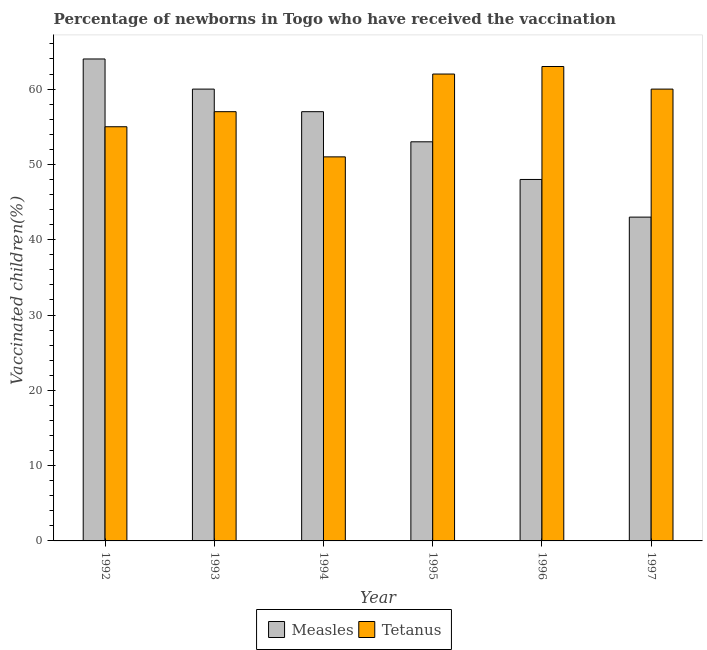Are the number of bars per tick equal to the number of legend labels?
Offer a very short reply. Yes. How many bars are there on the 5th tick from the left?
Offer a very short reply. 2. How many bars are there on the 6th tick from the right?
Provide a succinct answer. 2. What is the percentage of newborns who received vaccination for tetanus in 1995?
Make the answer very short. 62. Across all years, what is the maximum percentage of newborns who received vaccination for measles?
Keep it short and to the point. 64. Across all years, what is the minimum percentage of newborns who received vaccination for tetanus?
Your answer should be very brief. 51. What is the total percentage of newborns who received vaccination for measles in the graph?
Ensure brevity in your answer.  325. What is the difference between the percentage of newborns who received vaccination for tetanus in 1992 and that in 1993?
Give a very brief answer. -2. What is the difference between the percentage of newborns who received vaccination for measles in 1994 and the percentage of newborns who received vaccination for tetanus in 1992?
Give a very brief answer. -7. What is the average percentage of newborns who received vaccination for measles per year?
Your response must be concise. 54.17. What is the ratio of the percentage of newborns who received vaccination for tetanus in 1995 to that in 1997?
Ensure brevity in your answer.  1.03. What is the difference between the highest and the second highest percentage of newborns who received vaccination for measles?
Your answer should be very brief. 4. What is the difference between the highest and the lowest percentage of newborns who received vaccination for measles?
Offer a very short reply. 21. In how many years, is the percentage of newborns who received vaccination for measles greater than the average percentage of newborns who received vaccination for measles taken over all years?
Keep it short and to the point. 3. What does the 1st bar from the left in 1994 represents?
Offer a terse response. Measles. What does the 1st bar from the right in 1994 represents?
Keep it short and to the point. Tetanus. How many bars are there?
Offer a terse response. 12. Are all the bars in the graph horizontal?
Keep it short and to the point. No. How many years are there in the graph?
Keep it short and to the point. 6. What is the difference between two consecutive major ticks on the Y-axis?
Provide a short and direct response. 10. Are the values on the major ticks of Y-axis written in scientific E-notation?
Your answer should be very brief. No. How are the legend labels stacked?
Give a very brief answer. Horizontal. What is the title of the graph?
Make the answer very short. Percentage of newborns in Togo who have received the vaccination. Does "Crop" appear as one of the legend labels in the graph?
Ensure brevity in your answer.  No. What is the label or title of the X-axis?
Keep it short and to the point. Year. What is the label or title of the Y-axis?
Provide a short and direct response. Vaccinated children(%)
. What is the Vaccinated children(%)
 of Tetanus in 1994?
Your answer should be very brief. 51. What is the Vaccinated children(%)
 in Measles in 1995?
Provide a short and direct response. 53. What is the Vaccinated children(%)
 in Measles in 1997?
Provide a short and direct response. 43. Across all years, what is the maximum Vaccinated children(%)
 of Tetanus?
Ensure brevity in your answer.  63. Across all years, what is the minimum Vaccinated children(%)
 in Measles?
Provide a short and direct response. 43. Across all years, what is the minimum Vaccinated children(%)
 of Tetanus?
Provide a short and direct response. 51. What is the total Vaccinated children(%)
 of Measles in the graph?
Ensure brevity in your answer.  325. What is the total Vaccinated children(%)
 of Tetanus in the graph?
Give a very brief answer. 348. What is the difference between the Vaccinated children(%)
 in Tetanus in 1992 and that in 1993?
Offer a terse response. -2. What is the difference between the Vaccinated children(%)
 in Tetanus in 1992 and that in 1994?
Provide a succinct answer. 4. What is the difference between the Vaccinated children(%)
 in Tetanus in 1992 and that in 1995?
Give a very brief answer. -7. What is the difference between the Vaccinated children(%)
 in Measles in 1992 and that in 1997?
Offer a very short reply. 21. What is the difference between the Vaccinated children(%)
 in Tetanus in 1993 and that in 1994?
Provide a short and direct response. 6. What is the difference between the Vaccinated children(%)
 of Measles in 1993 and that in 1995?
Offer a very short reply. 7. What is the difference between the Vaccinated children(%)
 in Tetanus in 1993 and that in 1995?
Offer a terse response. -5. What is the difference between the Vaccinated children(%)
 of Tetanus in 1993 and that in 1996?
Your answer should be very brief. -6. What is the difference between the Vaccinated children(%)
 in Tetanus in 1993 and that in 1997?
Your response must be concise. -3. What is the difference between the Vaccinated children(%)
 in Measles in 1994 and that in 1995?
Provide a short and direct response. 4. What is the difference between the Vaccinated children(%)
 of Tetanus in 1994 and that in 1995?
Give a very brief answer. -11. What is the difference between the Vaccinated children(%)
 in Measles in 1994 and that in 1997?
Your answer should be compact. 14. What is the difference between the Vaccinated children(%)
 of Tetanus in 1994 and that in 1997?
Keep it short and to the point. -9. What is the difference between the Vaccinated children(%)
 in Tetanus in 1995 and that in 1996?
Your response must be concise. -1. What is the difference between the Vaccinated children(%)
 in Measles in 1995 and that in 1997?
Offer a very short reply. 10. What is the difference between the Vaccinated children(%)
 of Tetanus in 1995 and that in 1997?
Ensure brevity in your answer.  2. What is the difference between the Vaccinated children(%)
 of Measles in 1992 and the Vaccinated children(%)
 of Tetanus in 1993?
Keep it short and to the point. 7. What is the difference between the Vaccinated children(%)
 in Measles in 1993 and the Vaccinated children(%)
 in Tetanus in 1996?
Give a very brief answer. -3. What is the difference between the Vaccinated children(%)
 in Measles in 1993 and the Vaccinated children(%)
 in Tetanus in 1997?
Offer a terse response. 0. What is the difference between the Vaccinated children(%)
 of Measles in 1994 and the Vaccinated children(%)
 of Tetanus in 1995?
Give a very brief answer. -5. What is the difference between the Vaccinated children(%)
 in Measles in 1994 and the Vaccinated children(%)
 in Tetanus in 1996?
Your response must be concise. -6. What is the difference between the Vaccinated children(%)
 of Measles in 1995 and the Vaccinated children(%)
 of Tetanus in 1996?
Provide a succinct answer. -10. What is the average Vaccinated children(%)
 of Measles per year?
Offer a terse response. 54.17. In the year 1993, what is the difference between the Vaccinated children(%)
 in Measles and Vaccinated children(%)
 in Tetanus?
Your response must be concise. 3. In the year 1995, what is the difference between the Vaccinated children(%)
 of Measles and Vaccinated children(%)
 of Tetanus?
Provide a short and direct response. -9. In the year 1996, what is the difference between the Vaccinated children(%)
 in Measles and Vaccinated children(%)
 in Tetanus?
Offer a very short reply. -15. What is the ratio of the Vaccinated children(%)
 of Measles in 1992 to that in 1993?
Offer a very short reply. 1.07. What is the ratio of the Vaccinated children(%)
 in Tetanus in 1992 to that in 1993?
Offer a terse response. 0.96. What is the ratio of the Vaccinated children(%)
 in Measles in 1992 to that in 1994?
Make the answer very short. 1.12. What is the ratio of the Vaccinated children(%)
 of Tetanus in 1992 to that in 1994?
Ensure brevity in your answer.  1.08. What is the ratio of the Vaccinated children(%)
 of Measles in 1992 to that in 1995?
Offer a very short reply. 1.21. What is the ratio of the Vaccinated children(%)
 of Tetanus in 1992 to that in 1995?
Keep it short and to the point. 0.89. What is the ratio of the Vaccinated children(%)
 in Measles in 1992 to that in 1996?
Ensure brevity in your answer.  1.33. What is the ratio of the Vaccinated children(%)
 in Tetanus in 1992 to that in 1996?
Your answer should be very brief. 0.87. What is the ratio of the Vaccinated children(%)
 of Measles in 1992 to that in 1997?
Provide a short and direct response. 1.49. What is the ratio of the Vaccinated children(%)
 in Measles in 1993 to that in 1994?
Make the answer very short. 1.05. What is the ratio of the Vaccinated children(%)
 in Tetanus in 1993 to that in 1994?
Ensure brevity in your answer.  1.12. What is the ratio of the Vaccinated children(%)
 in Measles in 1993 to that in 1995?
Provide a short and direct response. 1.13. What is the ratio of the Vaccinated children(%)
 of Tetanus in 1993 to that in 1995?
Offer a very short reply. 0.92. What is the ratio of the Vaccinated children(%)
 of Measles in 1993 to that in 1996?
Provide a succinct answer. 1.25. What is the ratio of the Vaccinated children(%)
 in Tetanus in 1993 to that in 1996?
Your answer should be compact. 0.9. What is the ratio of the Vaccinated children(%)
 in Measles in 1993 to that in 1997?
Provide a short and direct response. 1.4. What is the ratio of the Vaccinated children(%)
 in Measles in 1994 to that in 1995?
Ensure brevity in your answer.  1.08. What is the ratio of the Vaccinated children(%)
 of Tetanus in 1994 to that in 1995?
Provide a short and direct response. 0.82. What is the ratio of the Vaccinated children(%)
 in Measles in 1994 to that in 1996?
Your answer should be very brief. 1.19. What is the ratio of the Vaccinated children(%)
 in Tetanus in 1994 to that in 1996?
Provide a short and direct response. 0.81. What is the ratio of the Vaccinated children(%)
 of Measles in 1994 to that in 1997?
Make the answer very short. 1.33. What is the ratio of the Vaccinated children(%)
 of Tetanus in 1994 to that in 1997?
Provide a succinct answer. 0.85. What is the ratio of the Vaccinated children(%)
 in Measles in 1995 to that in 1996?
Make the answer very short. 1.1. What is the ratio of the Vaccinated children(%)
 of Tetanus in 1995 to that in 1996?
Provide a short and direct response. 0.98. What is the ratio of the Vaccinated children(%)
 of Measles in 1995 to that in 1997?
Give a very brief answer. 1.23. What is the ratio of the Vaccinated children(%)
 in Measles in 1996 to that in 1997?
Ensure brevity in your answer.  1.12. What is the difference between the highest and the second highest Vaccinated children(%)
 in Measles?
Your response must be concise. 4. What is the difference between the highest and the second highest Vaccinated children(%)
 of Tetanus?
Give a very brief answer. 1. What is the difference between the highest and the lowest Vaccinated children(%)
 in Measles?
Provide a short and direct response. 21. 